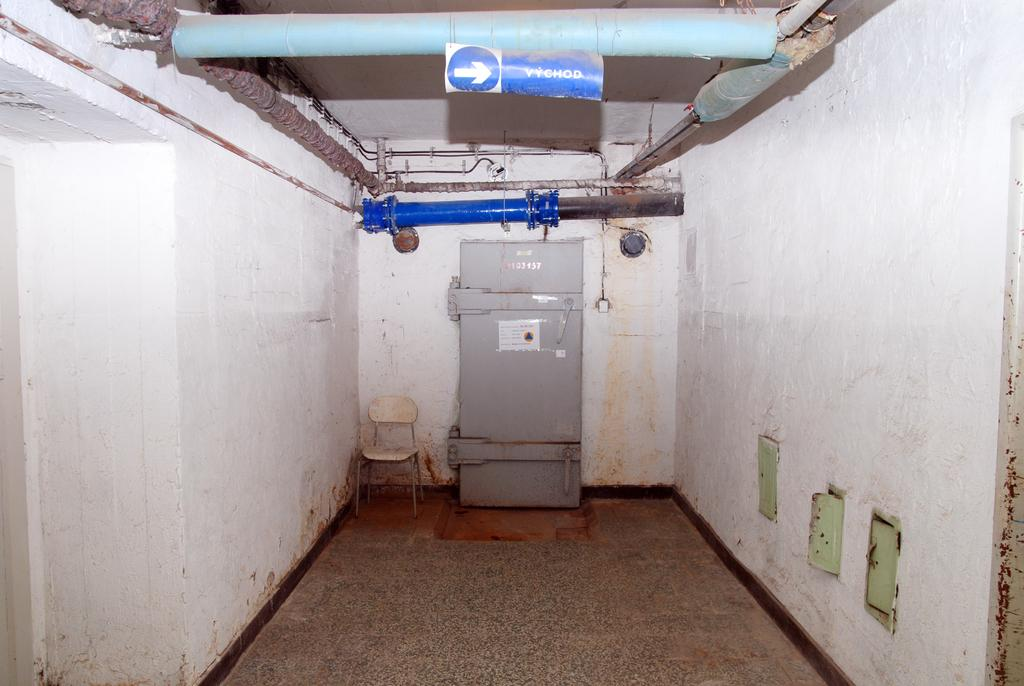<image>
Describe the image concisely. an arrow that is white in color and says chod 